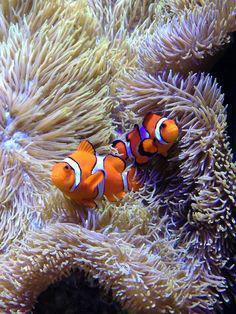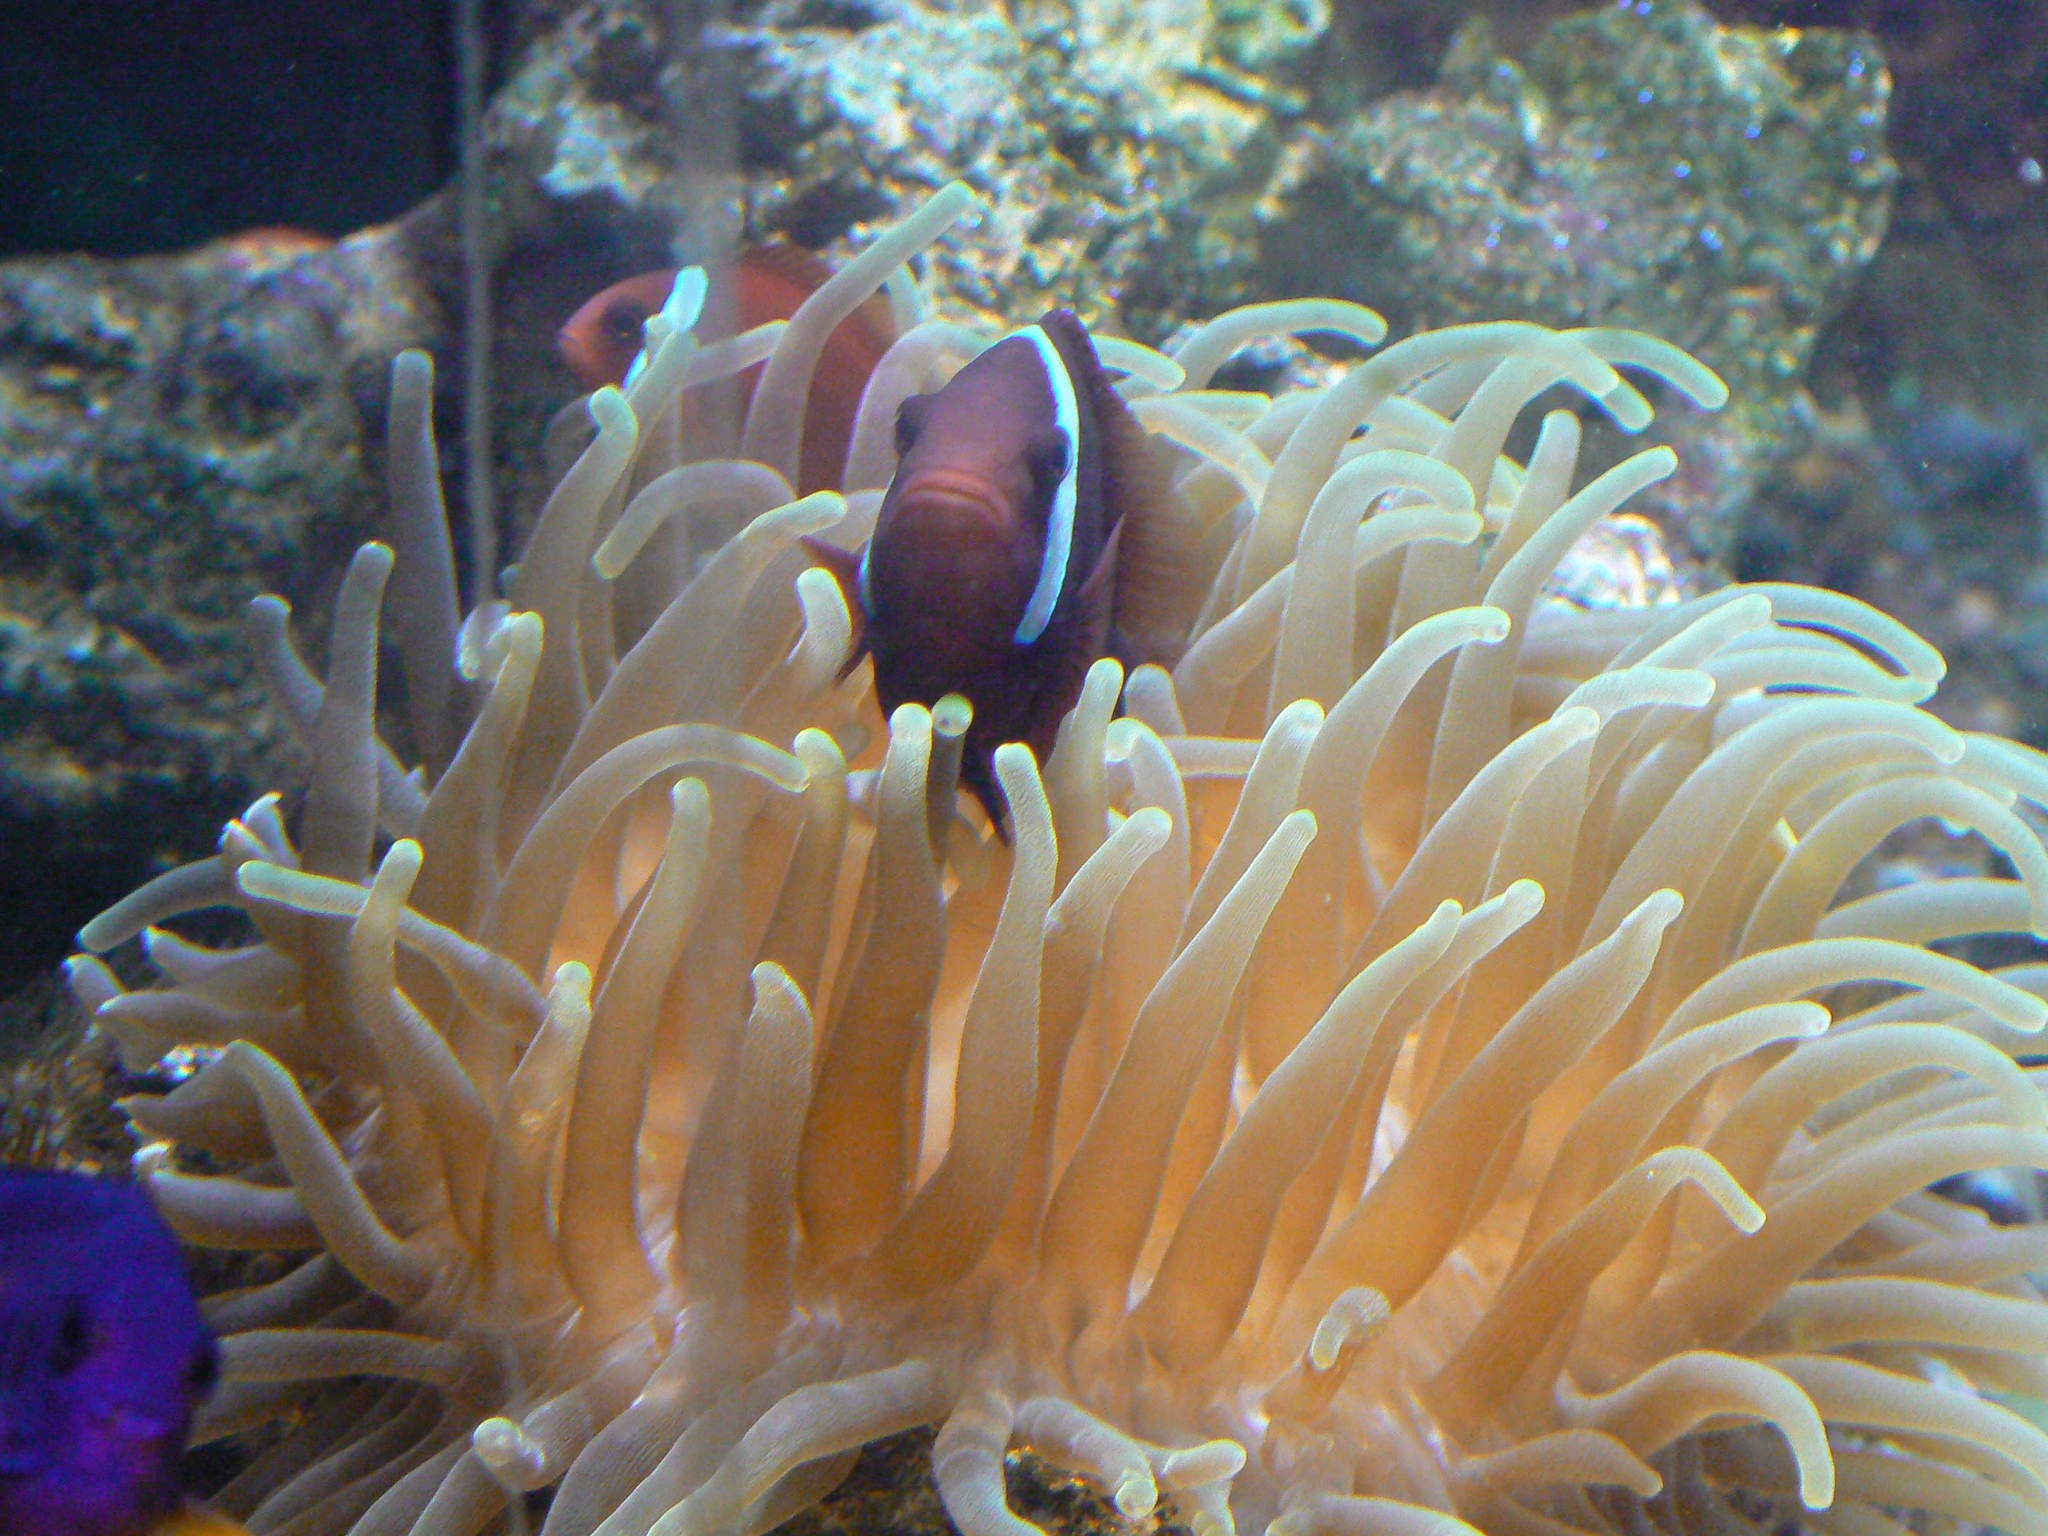The first image is the image on the left, the second image is the image on the right. Considering the images on both sides, is "The left image shows exactly two clown fish close together over anemone, and the right image includes a clown fish over white anemone tendrils." valid? Answer yes or no. Yes. 